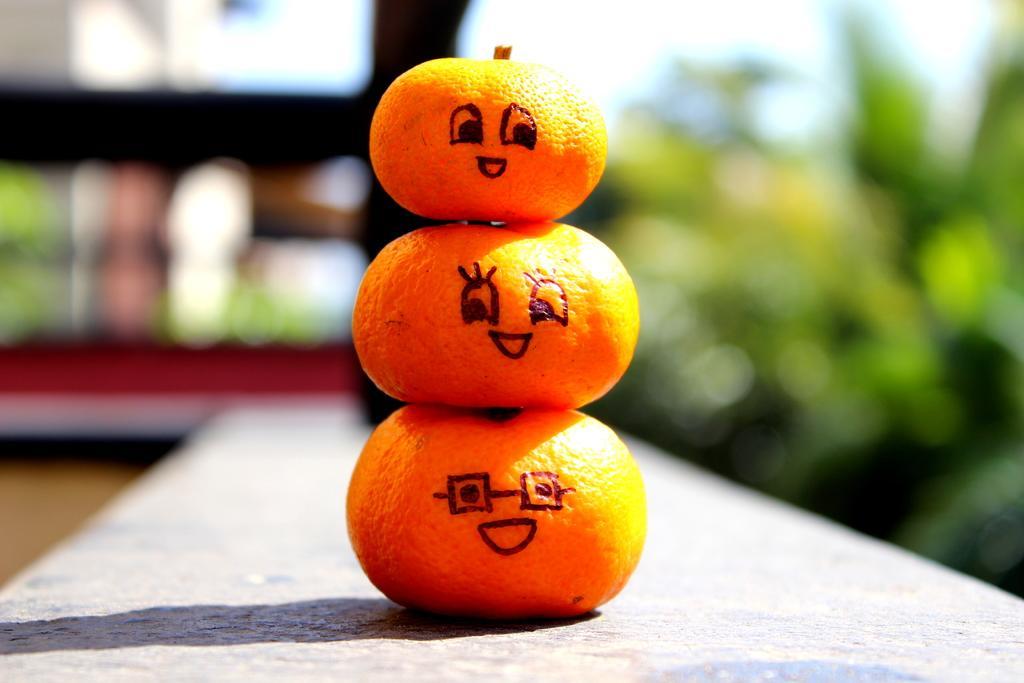How would you summarize this image in a sentence or two? In this picture there are three oranges are placed one on the other. On the oranges, the eyes and mouth are drawn with the marker. 